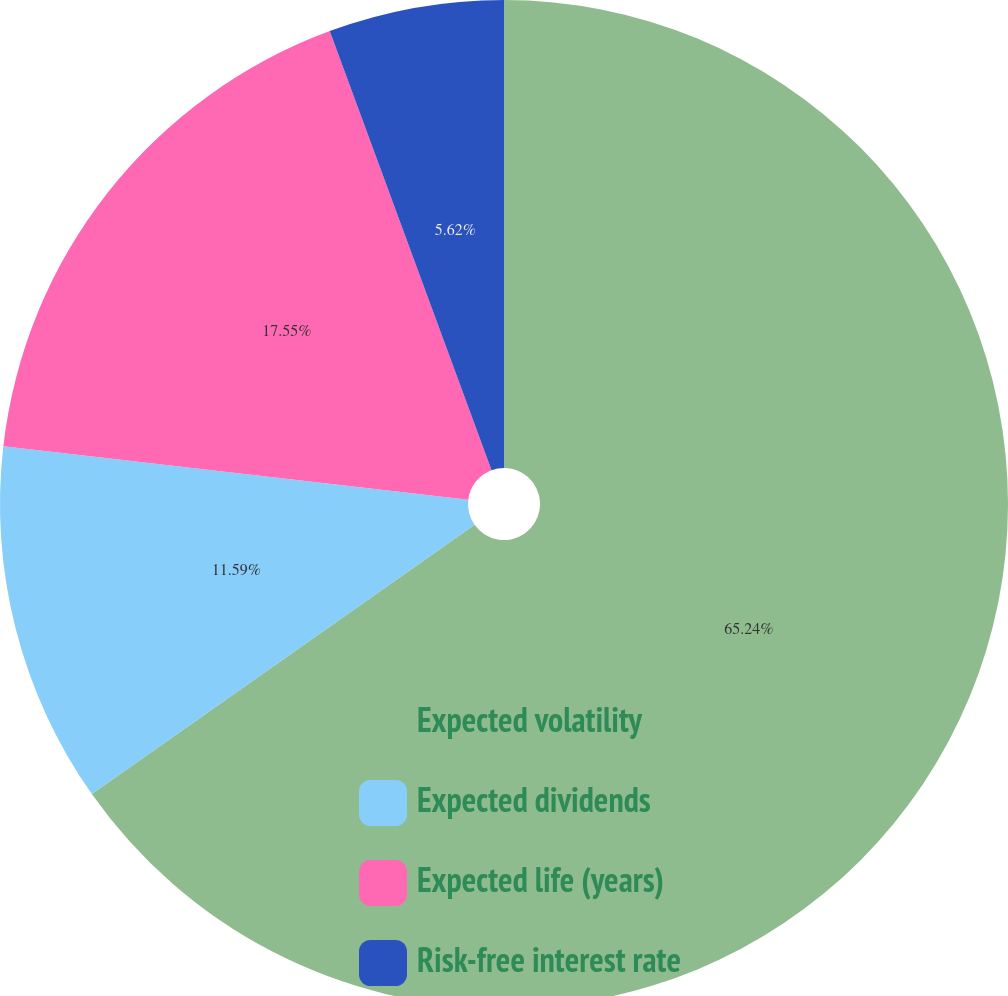Convert chart to OTSL. <chart><loc_0><loc_0><loc_500><loc_500><pie_chart><fcel>Expected volatility<fcel>Expected dividends<fcel>Expected life (years)<fcel>Risk-free interest rate<nl><fcel>65.24%<fcel>11.59%<fcel>17.55%<fcel>5.62%<nl></chart> 